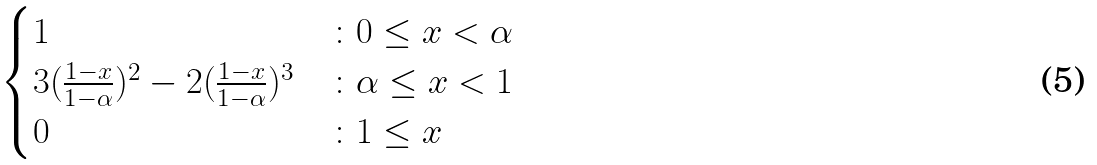<formula> <loc_0><loc_0><loc_500><loc_500>\begin{cases} 1 & \colon 0 \leq x < \alpha \\ 3 ( \frac { 1 - x } { 1 - \alpha } ) ^ { 2 } - 2 ( \frac { 1 - x } { 1 - \alpha } ) ^ { 3 } & \colon \alpha \leq x < 1 \\ 0 & \colon 1 \leq x \\ \end{cases}</formula> 